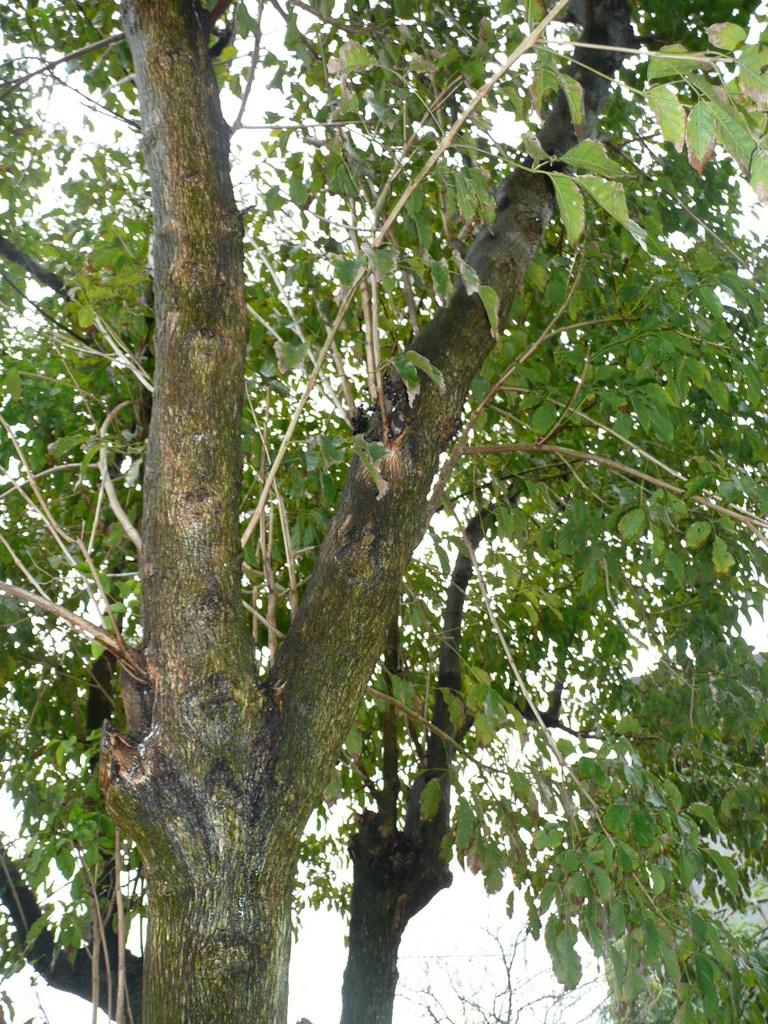What is located in the foreground of the image? There is a tree in the foreground of the image. What can be seen in the background on the right side? There is a building in the background on the right side. What is visible in the background of the image? The sky is visible in the background of the image. What type of drug can be seen in the image? There is no drug present in the image. What is the weather like in the image? The provided facts do not mention the weather, so it cannot be determined from the image. 